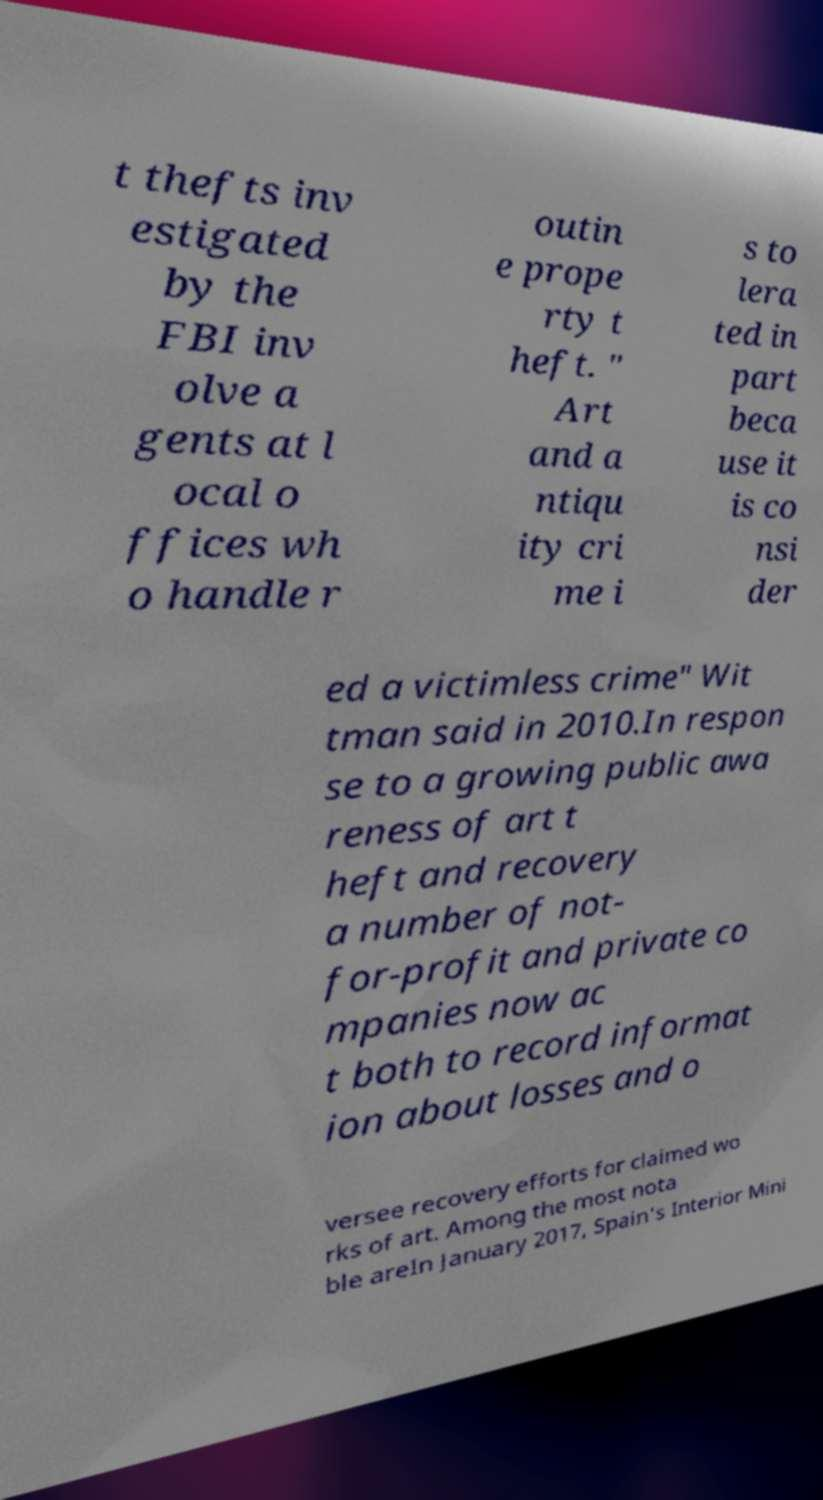Can you read and provide the text displayed in the image?This photo seems to have some interesting text. Can you extract and type it out for me? t thefts inv estigated by the FBI inv olve a gents at l ocal o ffices wh o handle r outin e prope rty t heft. " Art and a ntiqu ity cri me i s to lera ted in part beca use it is co nsi der ed a victimless crime" Wit tman said in 2010.In respon se to a growing public awa reness of art t heft and recovery a number of not- for-profit and private co mpanies now ac t both to record informat ion about losses and o versee recovery efforts for claimed wo rks of art. Among the most nota ble areIn January 2017, Spain's Interior Mini 